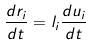<formula> <loc_0><loc_0><loc_500><loc_500>\frac { d r _ { i } } { d t } = l _ { i } \frac { d u _ { i } } { d t }</formula> 